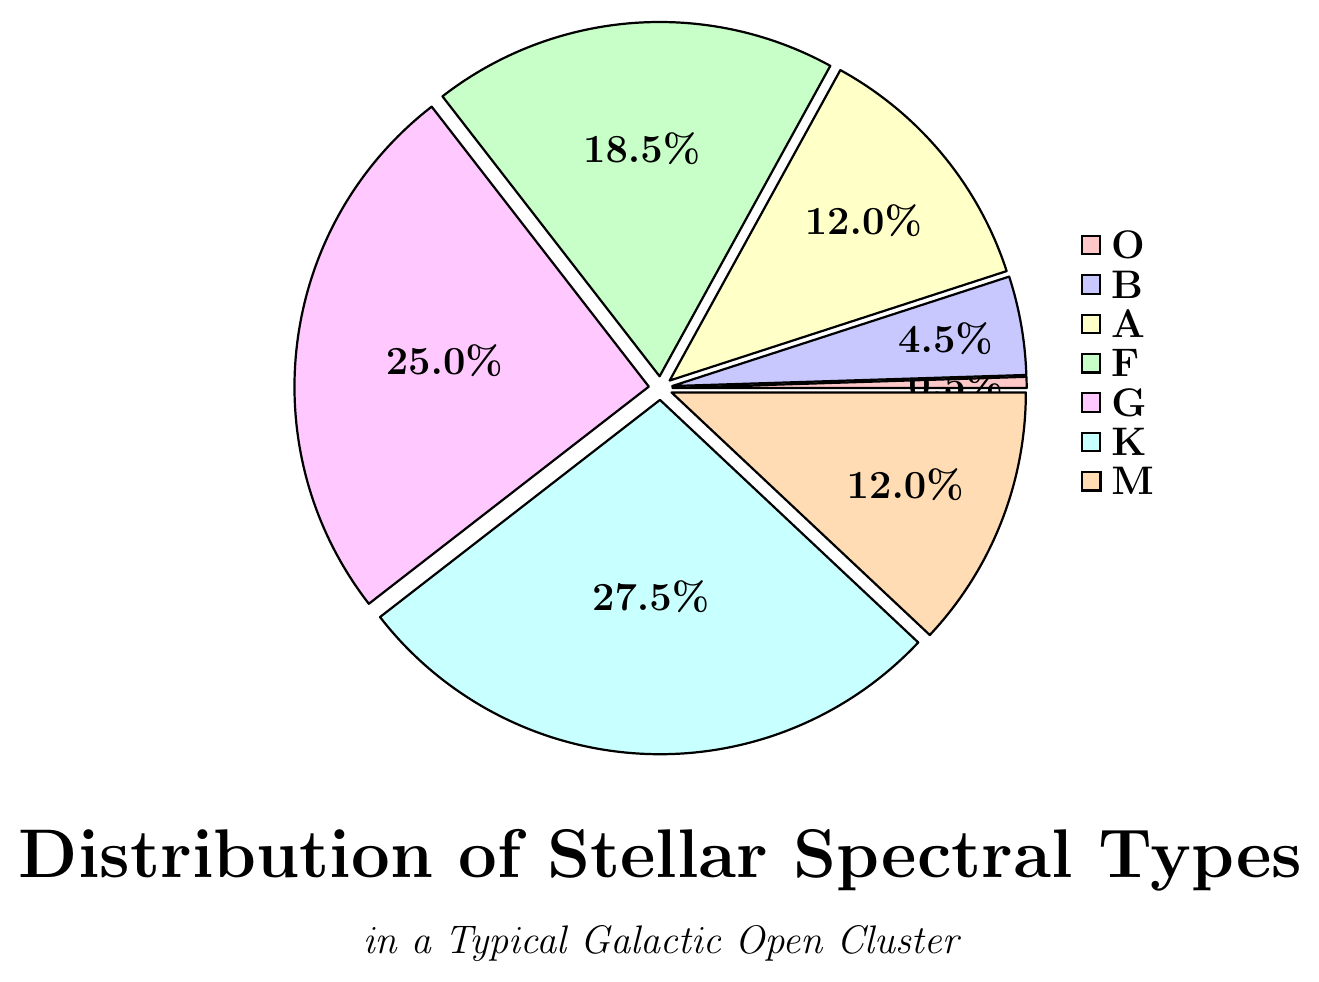Which spectral type has the highest percentage? The visual attributes of the pie chart indicate that the segment with the largest portion corresponds to the spectral type "K". Its segment occupies the largest area of the pie chart.
Answer: K Which spectral type has the lowest percentage? The visual attributes show that the smallest segment of the pie chart corresponds to the spectral type "O".
Answer: O What is the combined percentage of types A and F? The percentage values for types A and F are 12.0% and 18.5%, respectively. Adding these values gives 12.0% + 18.5% = 30.5%.
Answer: 30.5% How much more percentage does type G have compared to type B? The percentage value for type G is 25.0% while for type B it is 4.5%. Subtracting these gives 25.0% - 4.5% = 20.5%.
Answer: 20.5% Which types have the same percentage? Observing the pie chart, the types "A" and "M" both have segments labeled with 12.0%.
Answer: A and M What is the total percentage of spectral types that make up less than 10%? The spectral types with percentages less than 10% are "O" and "B" with 0.5% and 4.5%, respectively. Summing these gives 0.5% + 4.5% = 5.0%.
Answer: 5.0% What is the average percentage of spectral types F, G, and K? The percentages of spectral types F, G, and K are 18.5%, 25.0%, and 27.5%, respectively. Summing these gives 18.5% + 25.0% + 27.5% = 71.0%. Dividing by 3 (number of types) gives 71.0% / 3 ≈ 23.67%.
Answer: 23.67% Which type occupies a larger portion of the pie chart, type G or type M? The visual attributes of the pie chart show that the segment for type G is larger than the segment for type M.
Answer: G Is the percentage of type K more than double that of type A? The percentage of type K is 27.5%, and the percentage of type A is 12.0%. Double of 12.0% is 24.0%. Since 27.5% > 24.0%, the percentage of type K is more than double that of type A.
Answer: Yes 